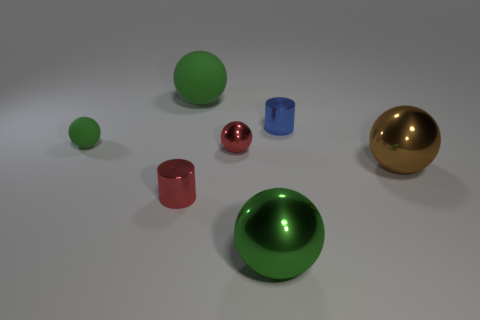There is a big matte thing that is the same color as the tiny matte ball; what is its shape? The object you're referring to is large and green, sharing its matte finish and color with the smaller ball nearby. Its shape is that of a hemisphere, exhibiting a flat base coupled with a domed top. 